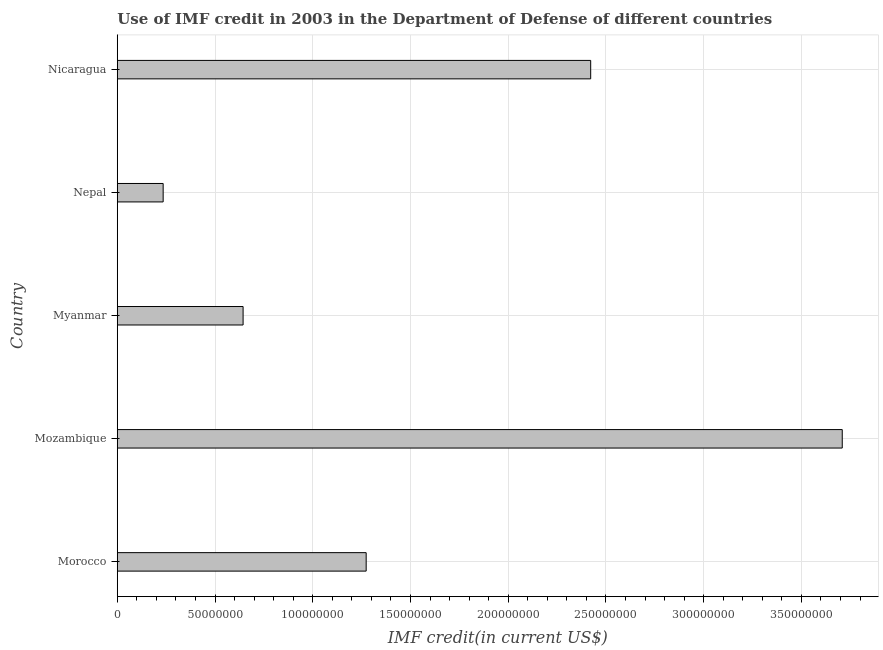Does the graph contain any zero values?
Your response must be concise. No. Does the graph contain grids?
Provide a short and direct response. Yes. What is the title of the graph?
Provide a short and direct response. Use of IMF credit in 2003 in the Department of Defense of different countries. What is the label or title of the X-axis?
Give a very brief answer. IMF credit(in current US$). What is the label or title of the Y-axis?
Your answer should be compact. Country. What is the use of imf credit in dod in Nicaragua?
Provide a short and direct response. 2.42e+08. Across all countries, what is the maximum use of imf credit in dod?
Offer a very short reply. 3.71e+08. Across all countries, what is the minimum use of imf credit in dod?
Give a very brief answer. 2.35e+07. In which country was the use of imf credit in dod maximum?
Offer a terse response. Mozambique. In which country was the use of imf credit in dod minimum?
Keep it short and to the point. Nepal. What is the sum of the use of imf credit in dod?
Your response must be concise. 8.28e+08. What is the difference between the use of imf credit in dod in Morocco and Nepal?
Keep it short and to the point. 1.04e+08. What is the average use of imf credit in dod per country?
Your response must be concise. 1.66e+08. What is the median use of imf credit in dod?
Make the answer very short. 1.27e+08. In how many countries, is the use of imf credit in dod greater than 280000000 US$?
Make the answer very short. 1. What is the ratio of the use of imf credit in dod in Morocco to that in Myanmar?
Make the answer very short. 1.98. Is the difference between the use of imf credit in dod in Morocco and Nicaragua greater than the difference between any two countries?
Make the answer very short. No. What is the difference between the highest and the second highest use of imf credit in dod?
Make the answer very short. 1.29e+08. What is the difference between the highest and the lowest use of imf credit in dod?
Your response must be concise. 3.47e+08. How many bars are there?
Provide a short and direct response. 5. How many countries are there in the graph?
Provide a succinct answer. 5. What is the IMF credit(in current US$) of Morocco?
Ensure brevity in your answer.  1.27e+08. What is the IMF credit(in current US$) of Mozambique?
Your answer should be very brief. 3.71e+08. What is the IMF credit(in current US$) in Myanmar?
Give a very brief answer. 6.44e+07. What is the IMF credit(in current US$) of Nepal?
Ensure brevity in your answer.  2.35e+07. What is the IMF credit(in current US$) in Nicaragua?
Your answer should be compact. 2.42e+08. What is the difference between the IMF credit(in current US$) in Morocco and Mozambique?
Make the answer very short. -2.44e+08. What is the difference between the IMF credit(in current US$) in Morocco and Myanmar?
Provide a short and direct response. 6.30e+07. What is the difference between the IMF credit(in current US$) in Morocco and Nepal?
Your response must be concise. 1.04e+08. What is the difference between the IMF credit(in current US$) in Morocco and Nicaragua?
Your answer should be compact. -1.15e+08. What is the difference between the IMF credit(in current US$) in Mozambique and Myanmar?
Offer a terse response. 3.07e+08. What is the difference between the IMF credit(in current US$) in Mozambique and Nepal?
Your answer should be compact. 3.47e+08. What is the difference between the IMF credit(in current US$) in Mozambique and Nicaragua?
Offer a terse response. 1.29e+08. What is the difference between the IMF credit(in current US$) in Myanmar and Nepal?
Offer a terse response. 4.09e+07. What is the difference between the IMF credit(in current US$) in Myanmar and Nicaragua?
Make the answer very short. -1.78e+08. What is the difference between the IMF credit(in current US$) in Nepal and Nicaragua?
Give a very brief answer. -2.19e+08. What is the ratio of the IMF credit(in current US$) in Morocco to that in Mozambique?
Ensure brevity in your answer.  0.34. What is the ratio of the IMF credit(in current US$) in Morocco to that in Myanmar?
Give a very brief answer. 1.98. What is the ratio of the IMF credit(in current US$) in Morocco to that in Nepal?
Give a very brief answer. 5.42. What is the ratio of the IMF credit(in current US$) in Morocco to that in Nicaragua?
Make the answer very short. 0.53. What is the ratio of the IMF credit(in current US$) in Mozambique to that in Myanmar?
Ensure brevity in your answer.  5.76. What is the ratio of the IMF credit(in current US$) in Mozambique to that in Nepal?
Offer a very short reply. 15.8. What is the ratio of the IMF credit(in current US$) in Mozambique to that in Nicaragua?
Make the answer very short. 1.53. What is the ratio of the IMF credit(in current US$) in Myanmar to that in Nepal?
Your response must be concise. 2.74. What is the ratio of the IMF credit(in current US$) in Myanmar to that in Nicaragua?
Ensure brevity in your answer.  0.27. What is the ratio of the IMF credit(in current US$) in Nepal to that in Nicaragua?
Your response must be concise. 0.1. 